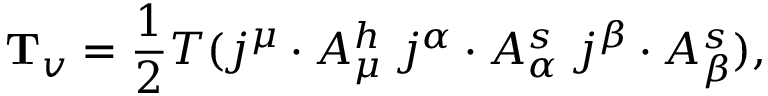<formula> <loc_0><loc_0><loc_500><loc_500>{ T } _ { v } = \frac { 1 } { 2 } T ( j ^ { \mu } \cdot A _ { \mu } ^ { h } \, j ^ { \alpha } \cdot A _ { \alpha } ^ { s } \, j ^ { \beta } \cdot A _ { \beta } ^ { s } ) ,</formula> 